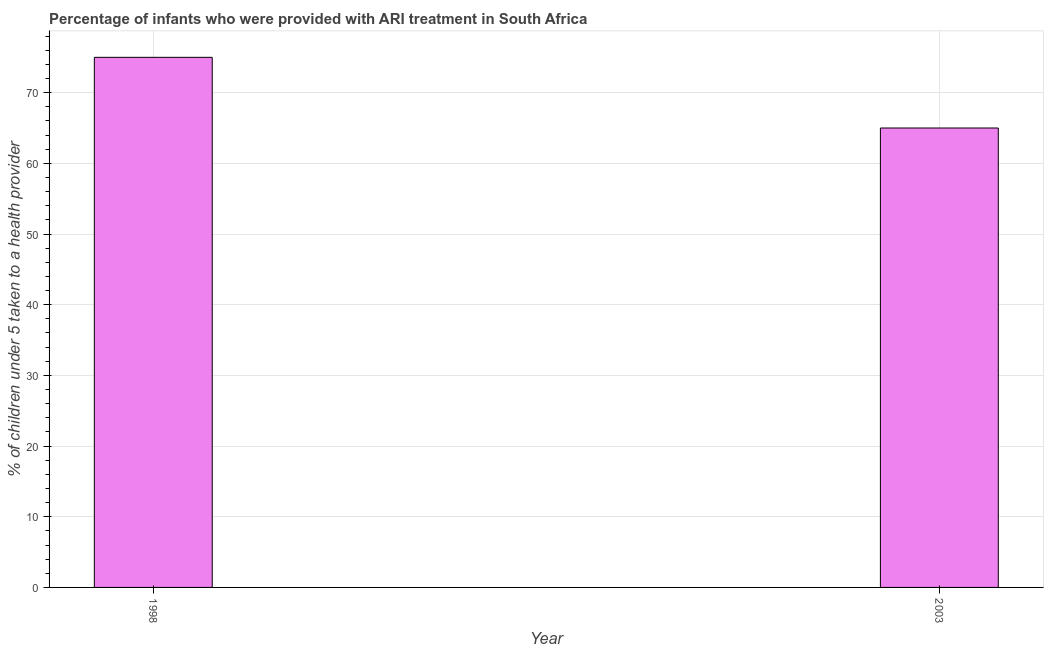Does the graph contain any zero values?
Your answer should be very brief. No. What is the title of the graph?
Your answer should be very brief. Percentage of infants who were provided with ARI treatment in South Africa. What is the label or title of the X-axis?
Offer a terse response. Year. What is the label or title of the Y-axis?
Your response must be concise. % of children under 5 taken to a health provider. What is the sum of the percentage of children who were provided with ari treatment?
Your answer should be very brief. 140. What is the difference between the percentage of children who were provided with ari treatment in 1998 and 2003?
Offer a terse response. 10. What is the ratio of the percentage of children who were provided with ari treatment in 1998 to that in 2003?
Provide a short and direct response. 1.15. How many years are there in the graph?
Make the answer very short. 2. What is the difference between two consecutive major ticks on the Y-axis?
Your answer should be very brief. 10. What is the % of children under 5 taken to a health provider of 1998?
Your response must be concise. 75. What is the difference between the % of children under 5 taken to a health provider in 1998 and 2003?
Offer a terse response. 10. What is the ratio of the % of children under 5 taken to a health provider in 1998 to that in 2003?
Provide a succinct answer. 1.15. 